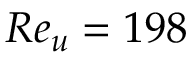Convert formula to latex. <formula><loc_0><loc_0><loc_500><loc_500>R e _ { u } = 1 9 8</formula> 